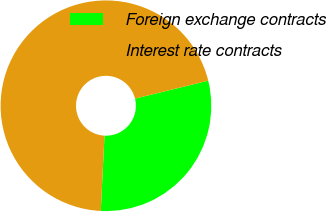<chart> <loc_0><loc_0><loc_500><loc_500><pie_chart><fcel>Foreign exchange contracts<fcel>Interest rate contracts<nl><fcel>29.61%<fcel>70.39%<nl></chart> 